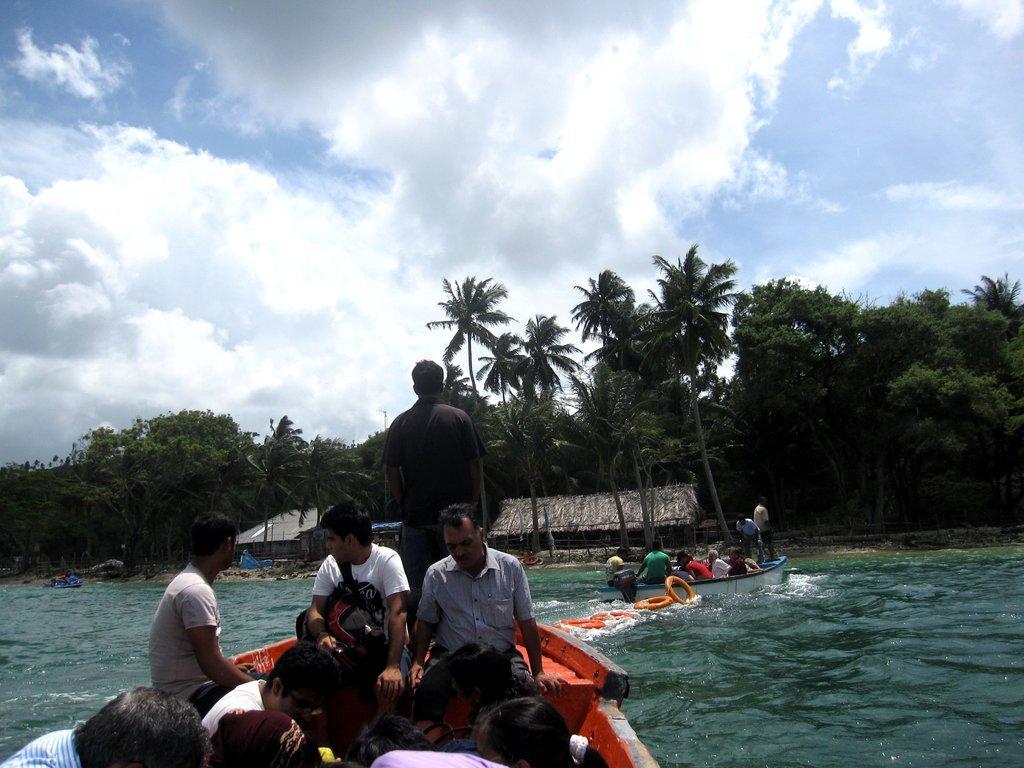Describe this image in one or two sentences. This image is taken outdoors. At the top of the image there is the sky with clouds. In the background there are many trees and plants with leaves, stems and branches. There are two two huts. In the middle of the image there are a few people sitting in the boats and sailing on the river. 